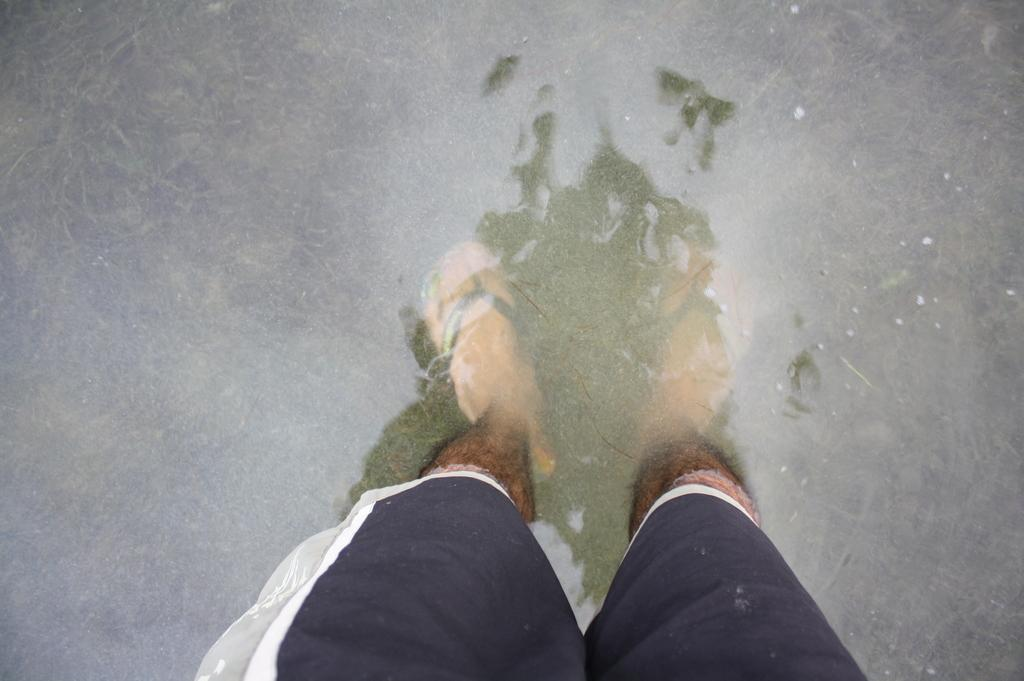What part of a person can be seen in the image? There are legs of a person visible in the image. Where are the legs located in relation to the water? The legs are inside the water. What type of instrument is being played by the children in the image? There are no children or instruments present in the image; it only shows legs inside the water. 